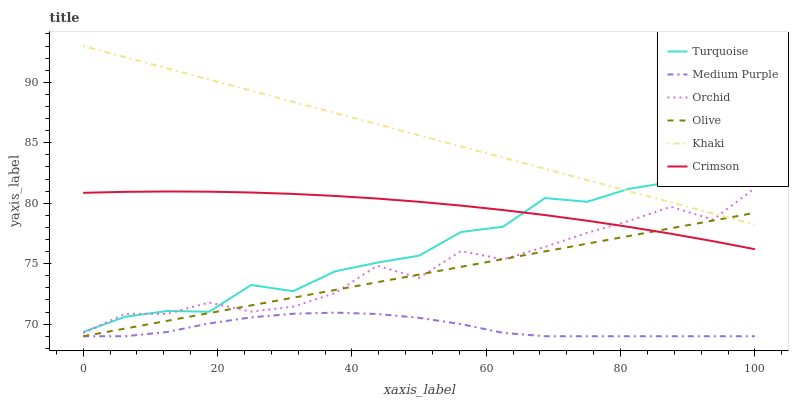Does Medium Purple have the minimum area under the curve?
Answer yes or no. Yes. Does Khaki have the maximum area under the curve?
Answer yes or no. Yes. Does Khaki have the minimum area under the curve?
Answer yes or no. No. Does Medium Purple have the maximum area under the curve?
Answer yes or no. No. Is Khaki the smoothest?
Answer yes or no. Yes. Is Orchid the roughest?
Answer yes or no. Yes. Is Medium Purple the smoothest?
Answer yes or no. No. Is Medium Purple the roughest?
Answer yes or no. No. Does Khaki have the lowest value?
Answer yes or no. No. Does Khaki have the highest value?
Answer yes or no. Yes. Does Medium Purple have the highest value?
Answer yes or no. No. Is Olive less than Turquoise?
Answer yes or no. Yes. Is Turquoise greater than Medium Purple?
Answer yes or no. Yes. Does Khaki intersect Turquoise?
Answer yes or no. Yes. Is Khaki less than Turquoise?
Answer yes or no. No. Is Khaki greater than Turquoise?
Answer yes or no. No. Does Olive intersect Turquoise?
Answer yes or no. No. 